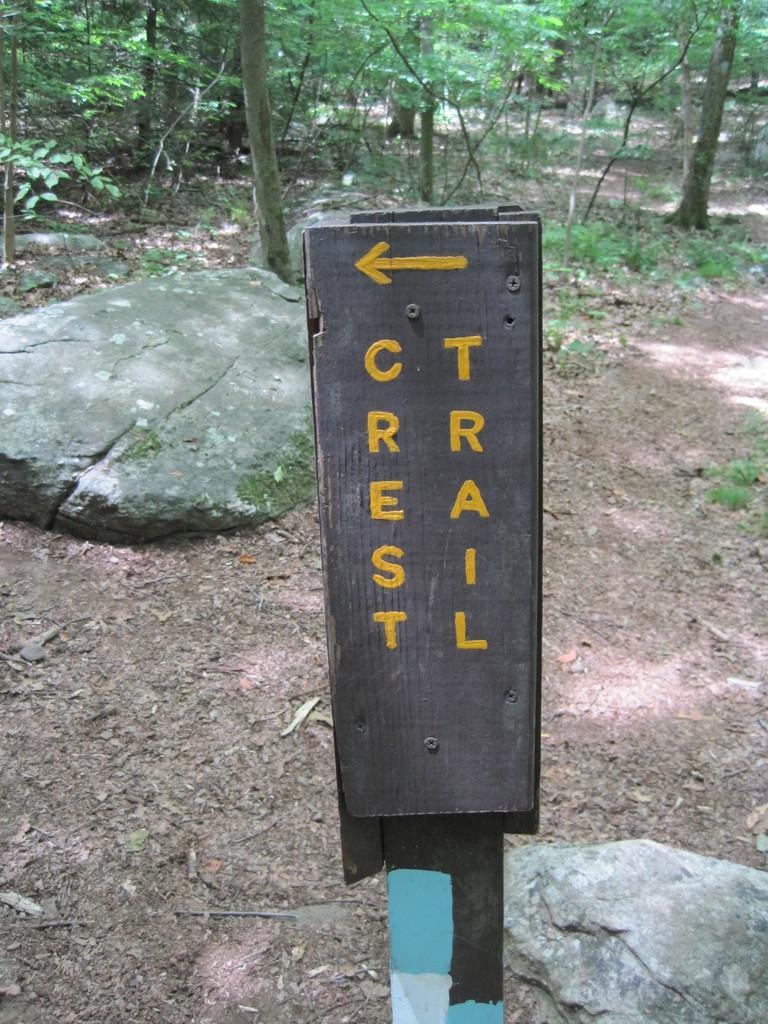Please provide a concise description of this image. In this image there is a board in the middle. On the board there is some text. In the background there is ground on which there are stones and trees. There is a stone beside the board. 